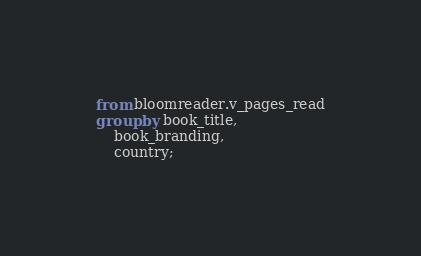<code> <loc_0><loc_0><loc_500><loc_500><_SQL_>from bloomreader.v_pages_read
group by book_title,
    book_branding,
    country;</code> 